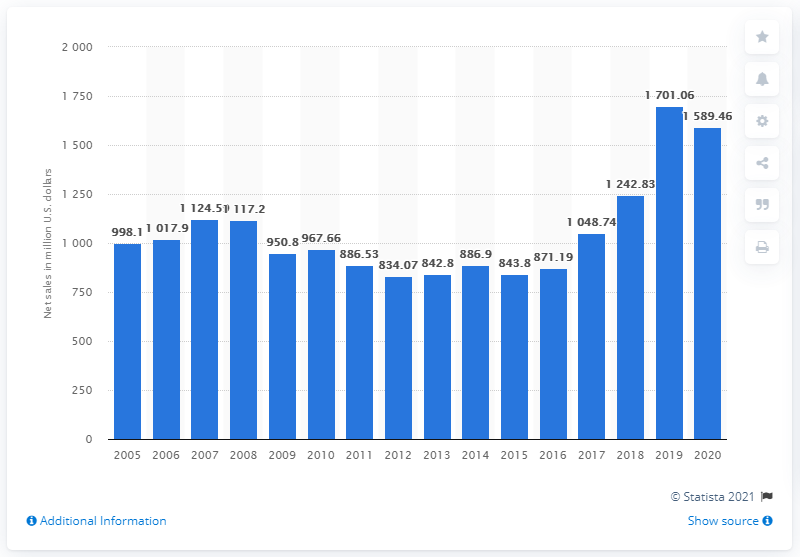Point out several critical features in this image. In 2020, the net sales of Callaway Golf were 1701.06. 